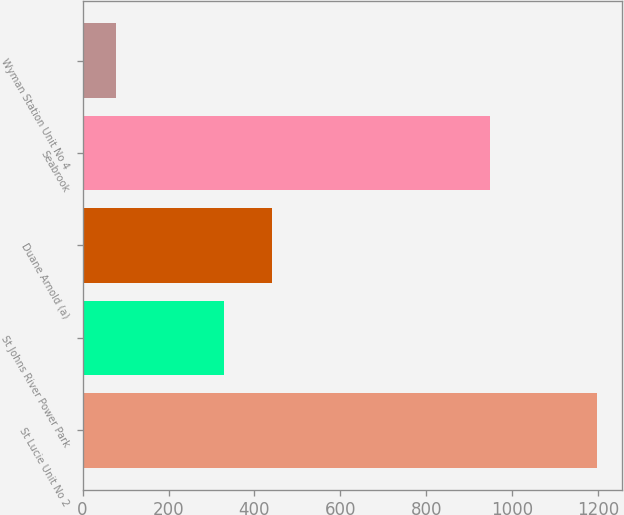<chart> <loc_0><loc_0><loc_500><loc_500><bar_chart><fcel>St Lucie Unit No 2<fcel>St Johns River Power Park<fcel>Duane Arnold (a)<fcel>Seabrook<fcel>Wyman Station Unit No 4<nl><fcel>1196<fcel>330<fcel>441.8<fcel>948<fcel>78<nl></chart> 